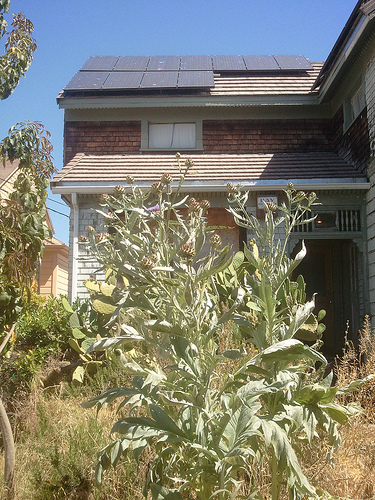<image>
Can you confirm if the tree is behind the wall? No. The tree is not behind the wall. From this viewpoint, the tree appears to be positioned elsewhere in the scene. 